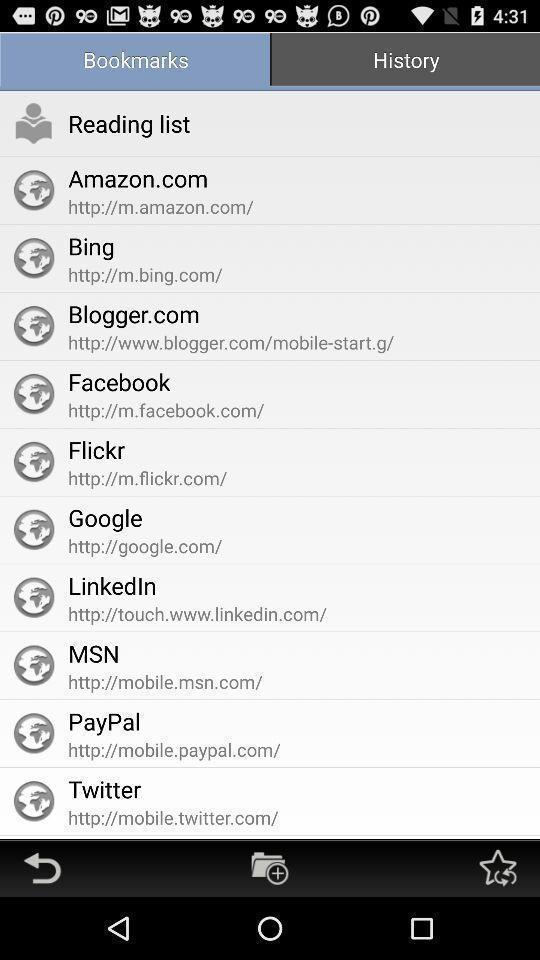Explain the elements present in this screenshot. Page showing a list of bookmarked links. 